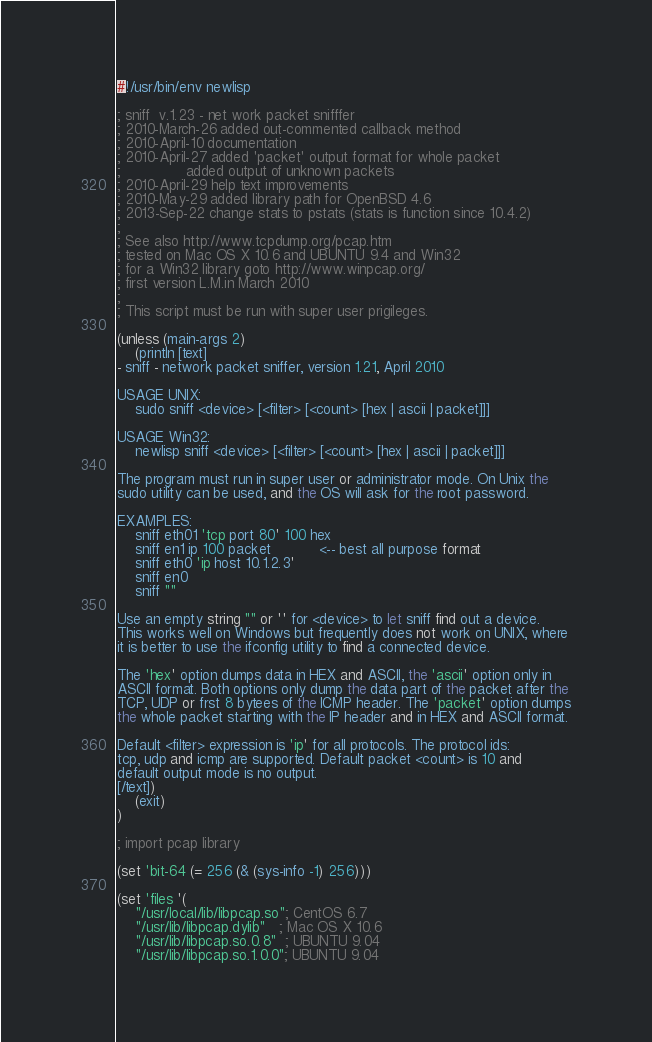Convert code to text. <code><loc_0><loc_0><loc_500><loc_500><_Lisp_>#!/usr/bin/env newlisp

; sniff  v.1.23 - net work packet snifffer
; 2010-March-26 added out-commented callback method
; 2010-April-10 documentation
; 2010-April-27 added 'packet' output format for whole packet
;               added output of unknown packets
; 2010-April-29 help text improvements
; 2010-May-29 added library path for OpenBSD 4.6 
; 2013-Sep-22 change stats to pstats (stats is function since 10.4.2)
;
; See also http://www.tcpdump.org/pcap.htm
; tested on Mac OS X 10.6 and UBUNTU 9.4 and Win32
; for a Win32 library goto http://www.winpcap.org/
; first version L.M.in March 2010
;
; This script must be run with super user prigileges.

(unless (main-args 2) 
	(println [text]
- sniff - network packet sniffer, version 1.21, April 2010

USAGE UNIX: 
    sudo sniff <device> [<filter> [<count> [hex | ascii | packet]]] 

USAGE Win32:
    newlisp sniff <device> [<filter> [<count> [hex | ascii | packet]]]   

The program must run in super user or administrator mode. On Unix the 
sudo utility can be used, and the OS will ask for the root password.

EXAMPLES: 
    sniff eth01 'tcp port 80' 100 hex
    sniff en1 ip 100 packet           <-- best all purpose format
    sniff eth0 'ip host 10.1.2.3'
    sniff en0
    sniff ""
    
Use an empty string "" or '' for <device> to let sniff find out a device.
This works well on Windows but frequently does not work on UNIX, where
it is better to use the ifconfig utility to find a connected device. 

The 'hex' option dumps data in HEX and ASCII, the 'ascii' option only in 
ASCII format. Both options only dump the data part of the packet after the 
TCP, UDP or frst 8 bytees of the ICMP header. The 'packet' option dumps
the whole packet starting with the IP header and in HEX and ASCII format. 

Default <filter> expression is 'ip' for all protocols. The protocol ids:
tcp, udp and icmp are supported. Default packet <count> is 10 and 
default output mode is no output.
[/text])
	(exit)
)

; import pcap library

(set 'bit-64 (= 256 (& (sys-info -1) 256)))

(set 'files '(
    "/usr/local/lib/libpcap.so"; CentOS 6.7
	"/usr/lib/libpcap.dylib"   ; Mac OS X 10.6
	"/usr/lib/libpcap.so.0.8"  ; UBUNTU 9.04
	"/usr/lib/libpcap.so.1.0.0"; UBUNTU 9.04</code> 